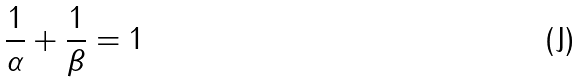<formula> <loc_0><loc_0><loc_500><loc_500>\frac { 1 } { \alpha } + \frac { 1 } { \beta } = 1</formula> 